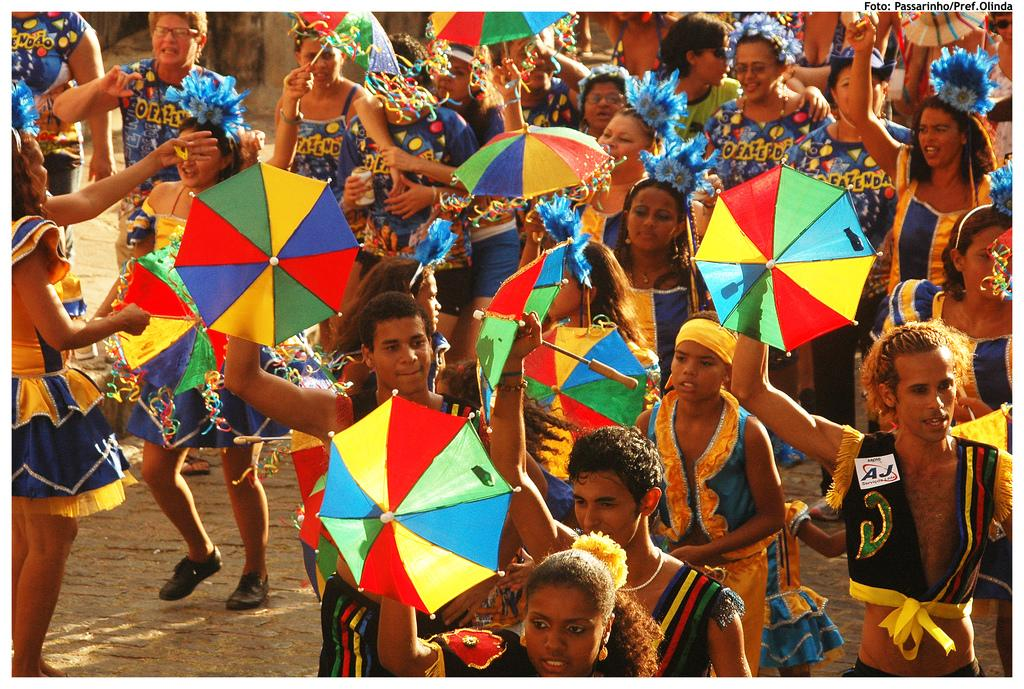<image>
Provide a brief description of the given image. A group of men and women with rainbow umbrellas, one with a name tag AJ 